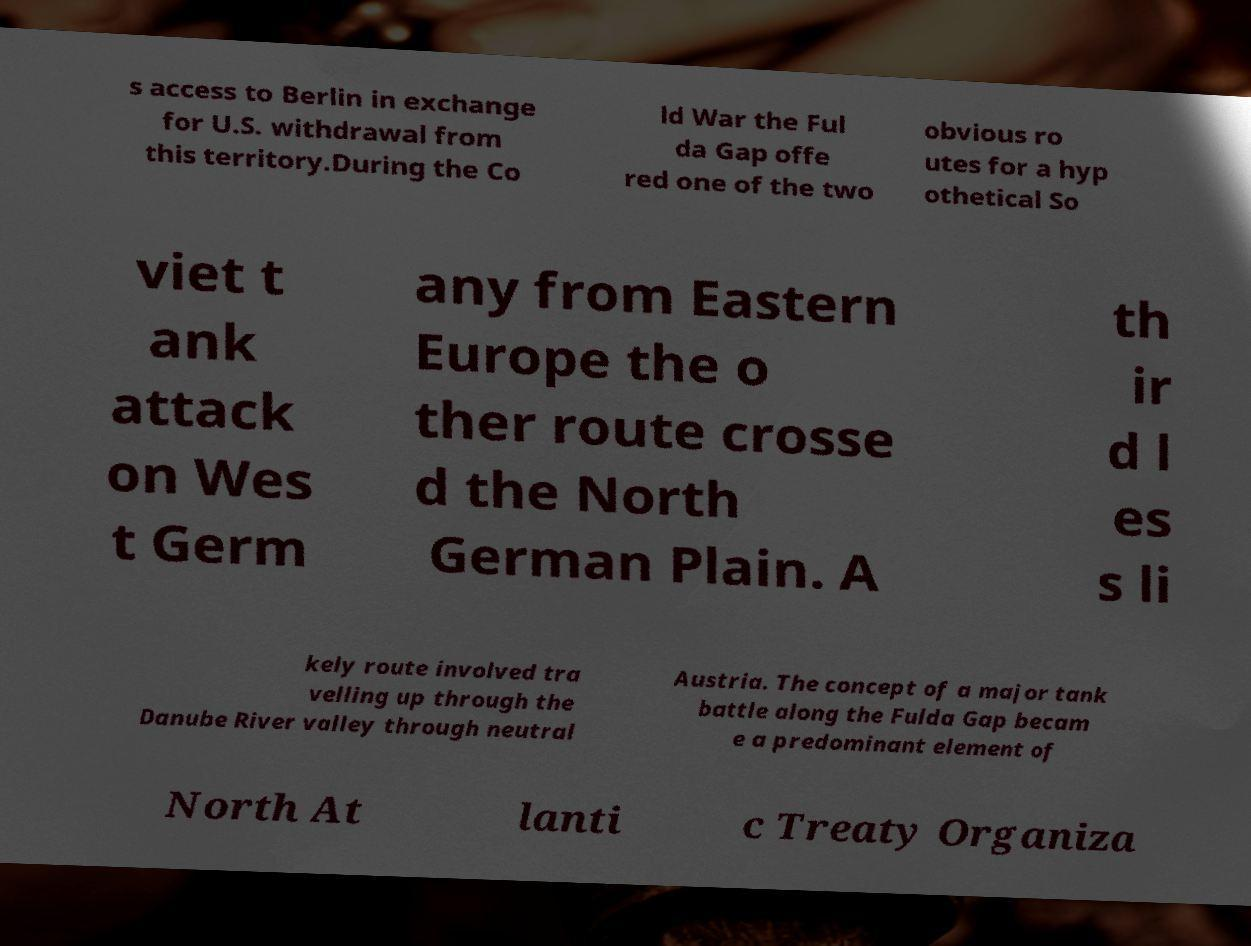Could you extract and type out the text from this image? s access to Berlin in exchange for U.S. withdrawal from this territory.During the Co ld War the Ful da Gap offe red one of the two obvious ro utes for a hyp othetical So viet t ank attack on Wes t Germ any from Eastern Europe the o ther route crosse d the North German Plain. A th ir d l es s li kely route involved tra velling up through the Danube River valley through neutral Austria. The concept of a major tank battle along the Fulda Gap becam e a predominant element of North At lanti c Treaty Organiza 